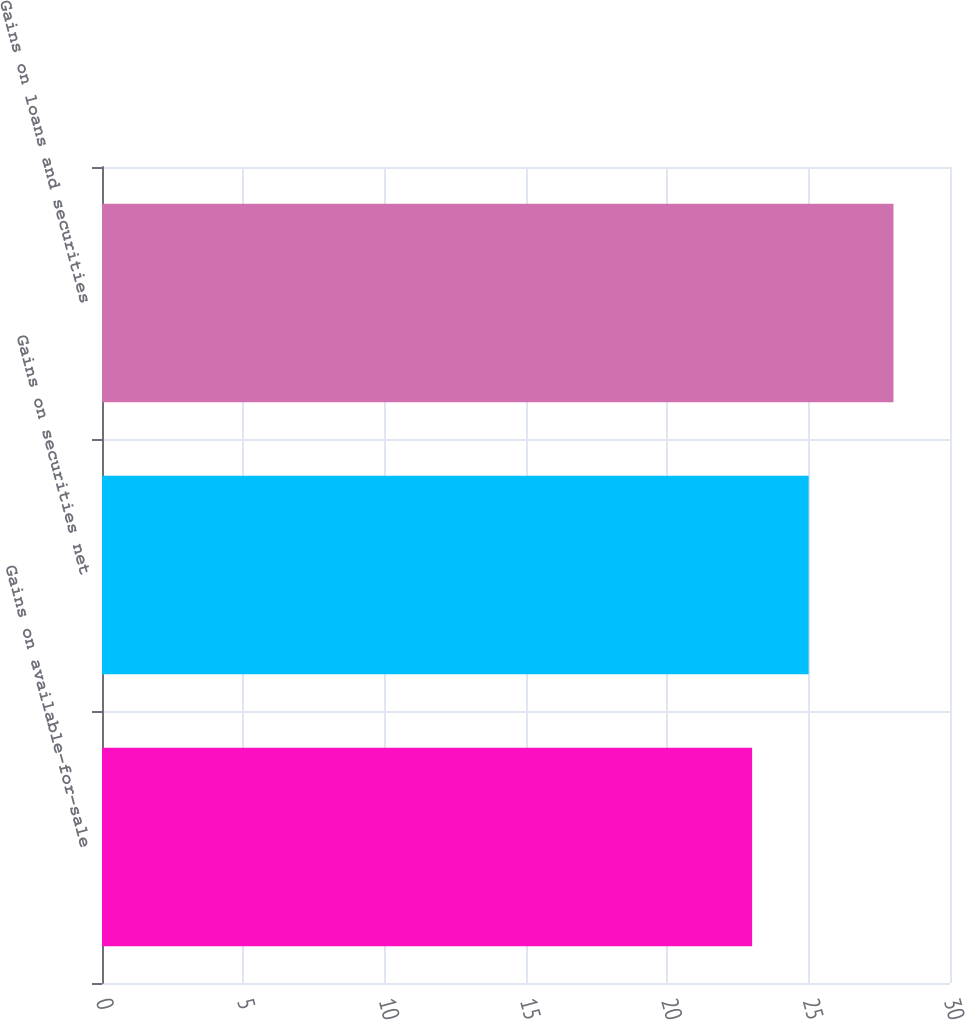Convert chart. <chart><loc_0><loc_0><loc_500><loc_500><bar_chart><fcel>Gains on available-for-sale<fcel>Gains on securities net<fcel>Gains on loans and securities<nl><fcel>23<fcel>25<fcel>28<nl></chart> 